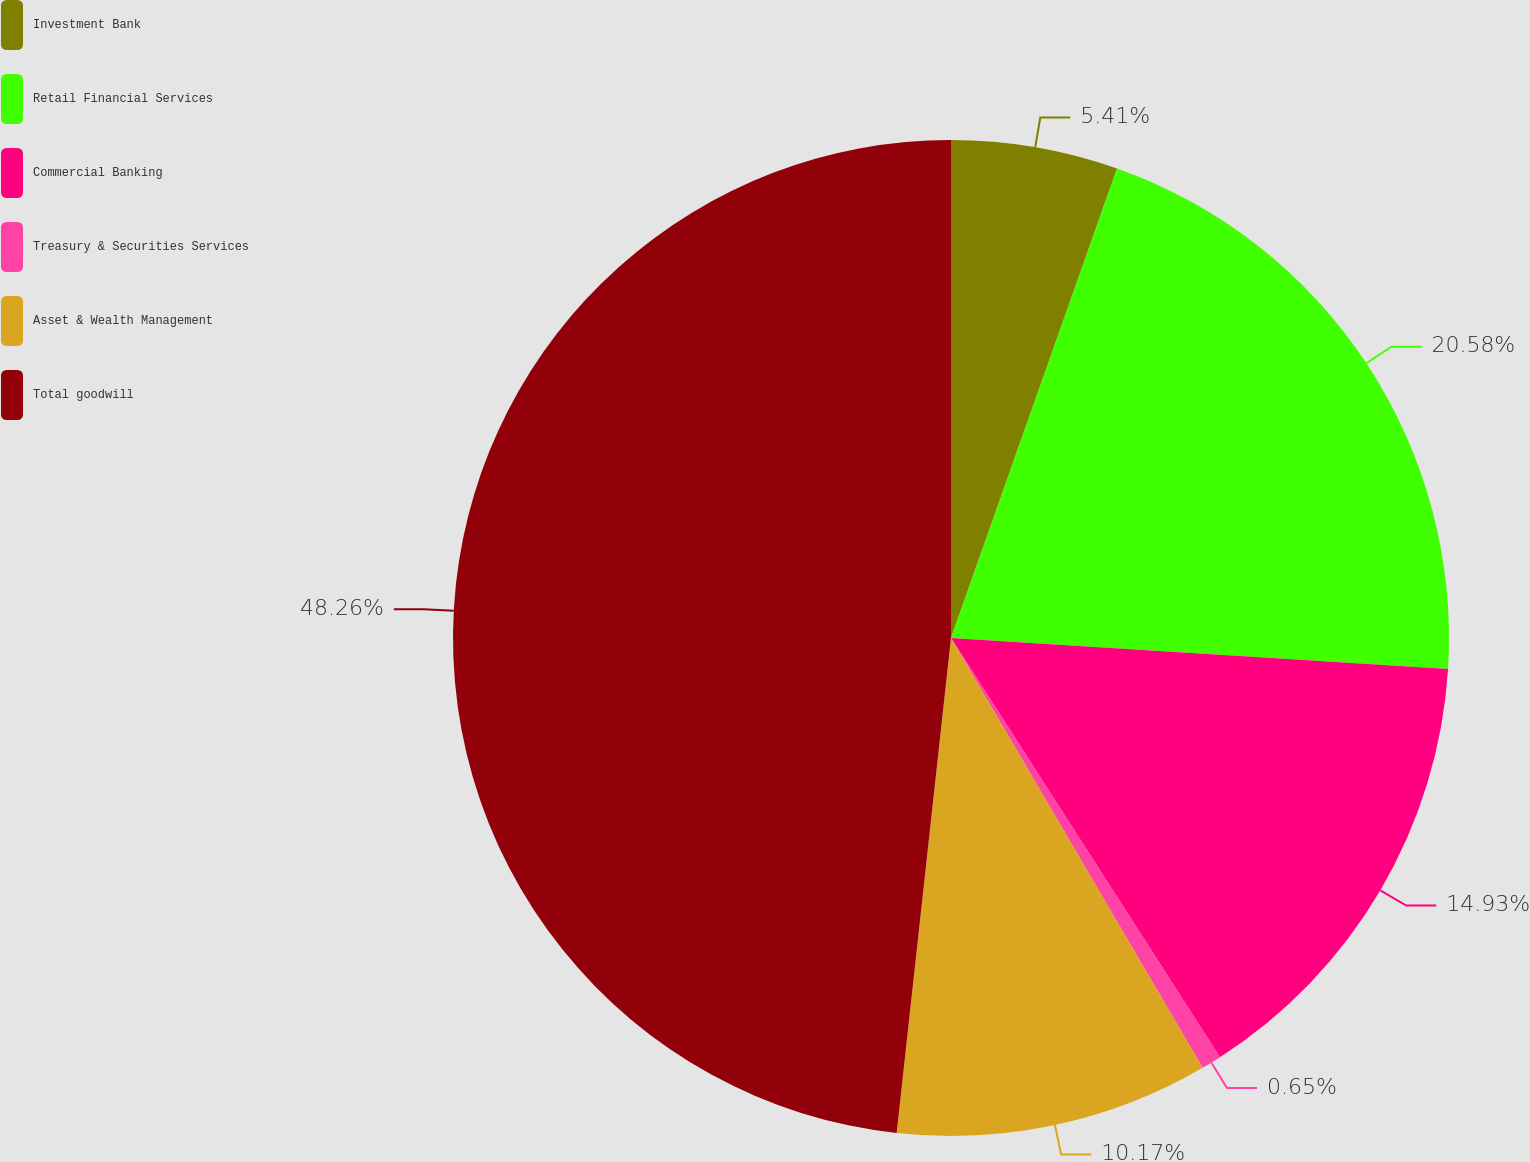<chart> <loc_0><loc_0><loc_500><loc_500><pie_chart><fcel>Investment Bank<fcel>Retail Financial Services<fcel>Commercial Banking<fcel>Treasury & Securities Services<fcel>Asset & Wealth Management<fcel>Total goodwill<nl><fcel>5.41%<fcel>20.58%<fcel>14.93%<fcel>0.65%<fcel>10.17%<fcel>48.26%<nl></chart> 